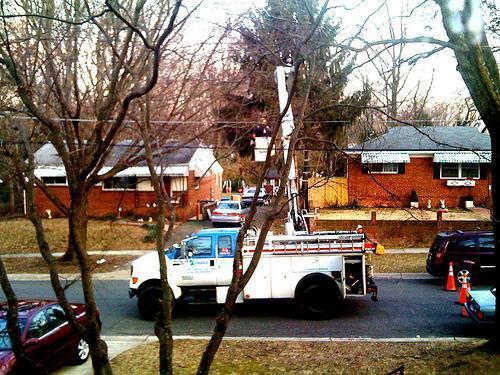How many houses are in the picture?
Give a very brief answer. 2. How many people are in this picture?
Give a very brief answer. 1. 